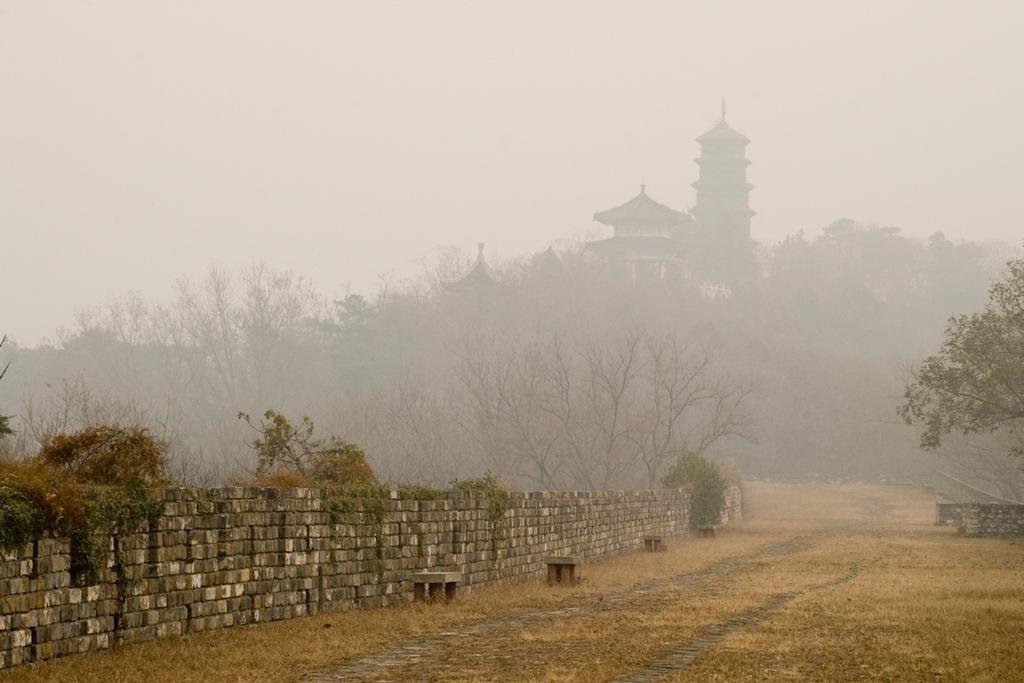Can you describe this image briefly? In this picture we can see a wall, few trees and buildings. 